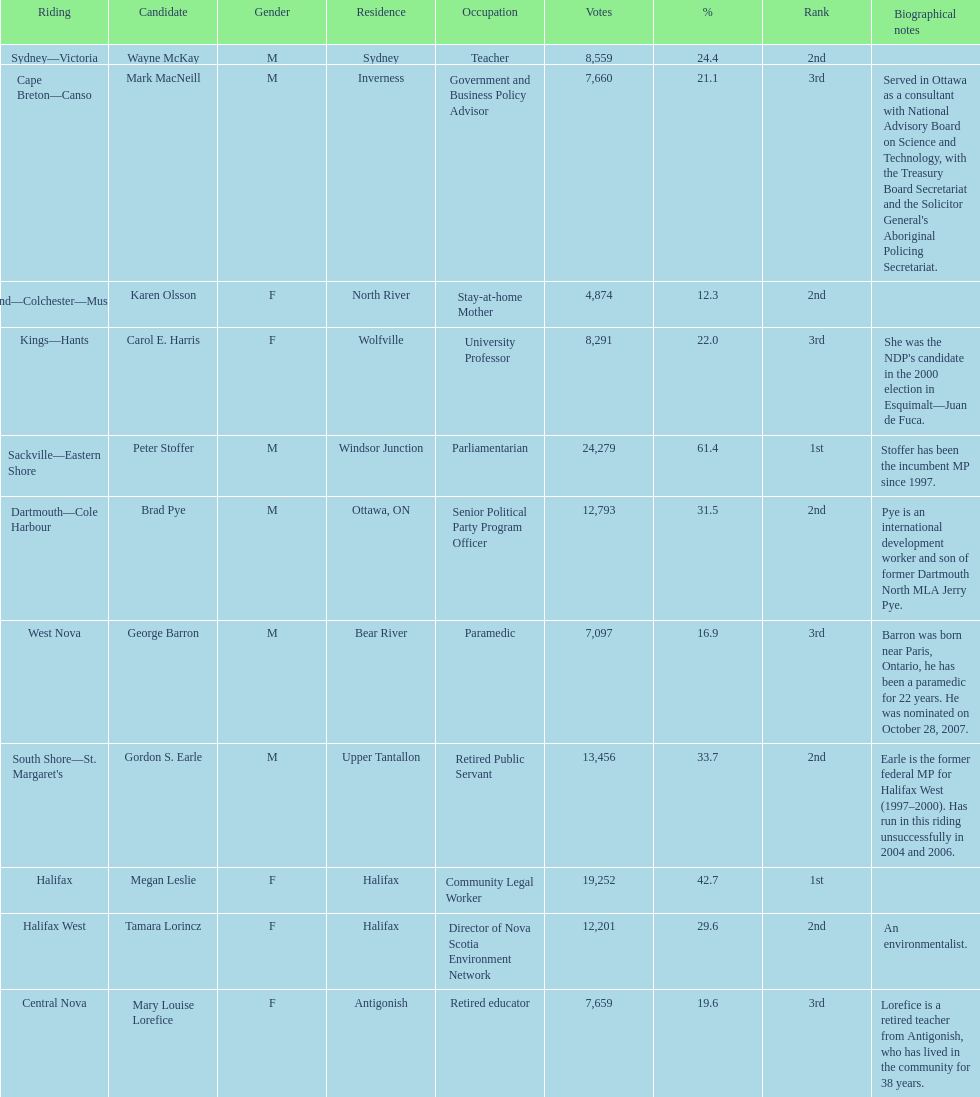What is the first riding? Cape Breton-Canso. 